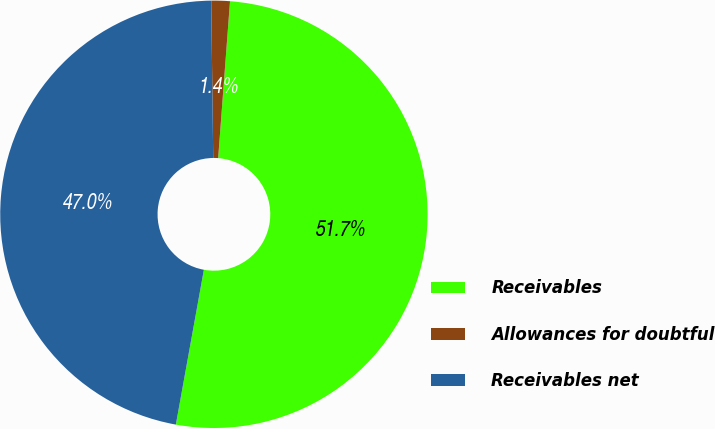<chart> <loc_0><loc_0><loc_500><loc_500><pie_chart><fcel>Receivables<fcel>Allowances for doubtful<fcel>Receivables net<nl><fcel>51.65%<fcel>1.4%<fcel>46.95%<nl></chart> 